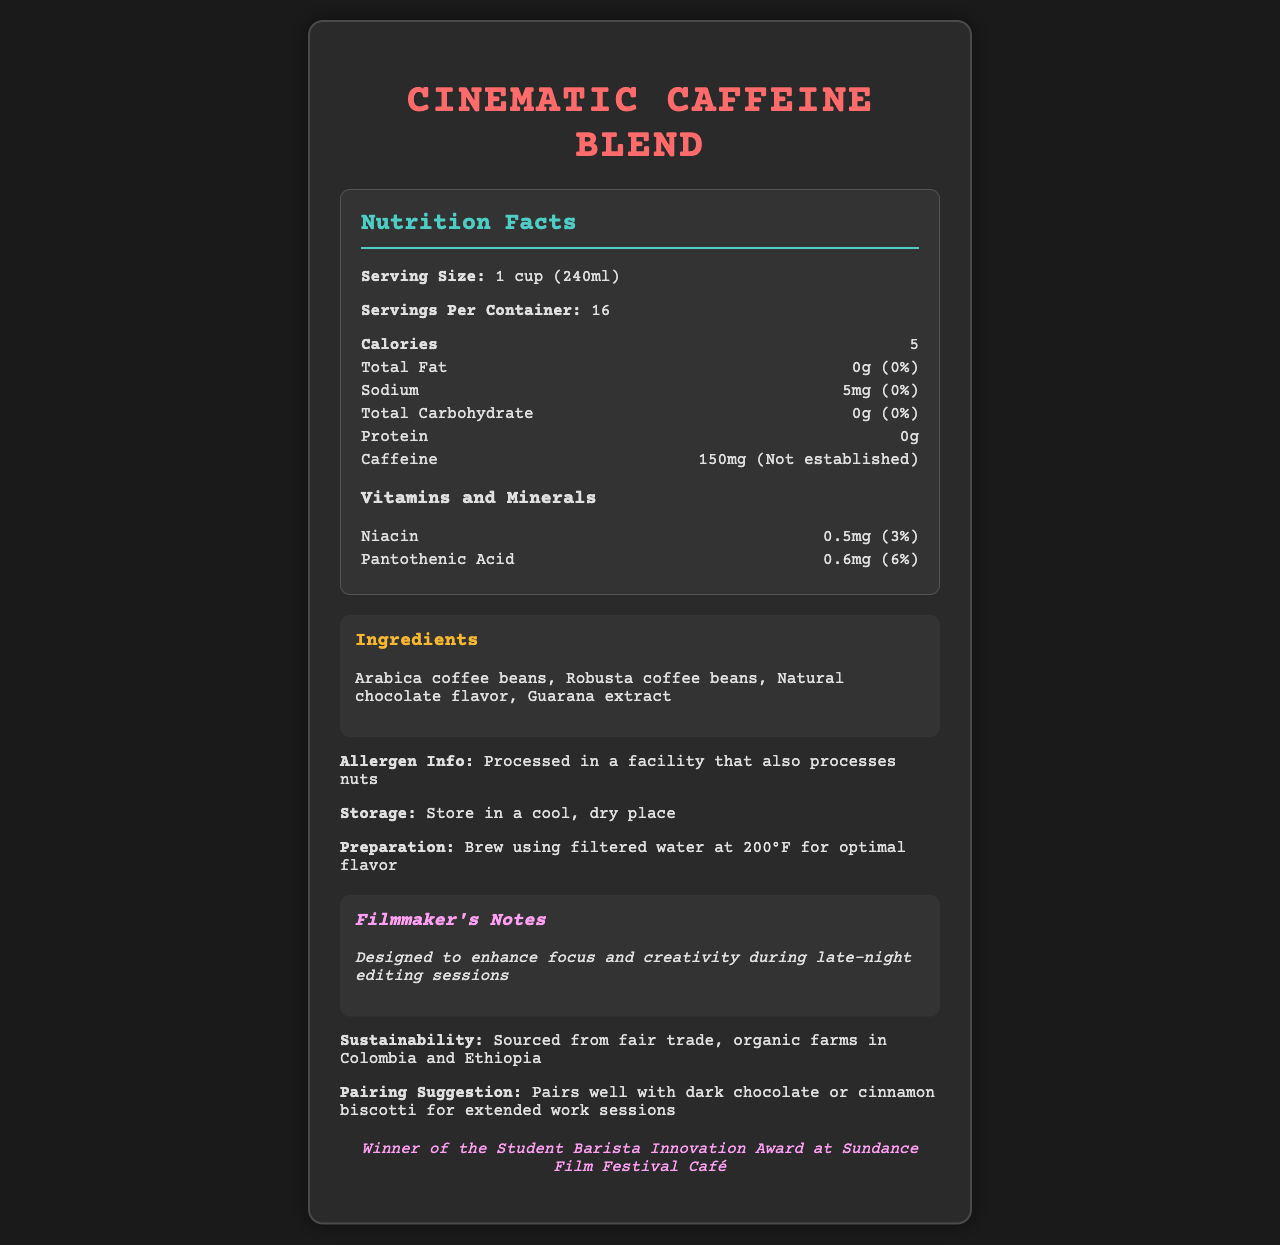What is the serving size of the Cinematic Caffeine Blend? The Nutrition Facts label lists the serving size as "1 cup (240ml)".
Answer: 1 cup (240ml) How many servings are in one container? The document specifies that there are 16 servings per container.
Answer: 16 What is the main source of flavor added to the coffee blend? Under ingredients, "Natural chocolate flavor" is listed as one of the components.
Answer: Natural chocolate flavor How much sodium is in one serving? The label shows sodium content as "5mg".
Answer: 5mg What specific vitamin contributes to 6% of the daily value? The vitamins and minerals section indicates that Pantothenic Acid contributes 6% of the daily value.
Answer: Pantothenic Acid What is the caffeine content per serving? The nutrition item for caffeine lists it as "150mg".
Answer: 150mg Which of the following awards has the product won? A. Best Coffee Blend at Coffee Expo B. Student Barista Innovation Award at Sundance Film Festival Café C. Most Sustainable Coffee of the Year D. People's Choice Award at Coffee Lovers Meeting The awards section states: "Winner of the Student Barista Innovation Award at Sundance Film Festival Café".
Answer: B What preparation instructions are given for brewing the coffee? A. Use filtered water at 180°F B. Use purified water at 190°F C. Use filtered water at 200°F D. Use tap water at 195°F The preparation instructions specify: "Brew using filtered water at 200°F for optimal flavor".
Answer: C Is this product suitable for people with nut allergies? The allergen info states: "Processed in a facility that also processes nuts".
Answer: No Summarize the main idea of this document. The document encompasses various aspects of the Cinematic Caffeine Blend from nutritional details to its awards and sustainability, catering specifically to filmmakers and students requiring long-lasting focus.
Answer: The document provides comprehensive details about the Cinematic Caffeine Blend, outlining its nutritional facts, ingredients, awards, sustainability efforts, and recommendations for usage. It highlights the coffee's benefits for late-night editing, suggesting it enhances focus and creativity, and includes detailed preparation and storage instructions. How much total fat is contained in a serving? The total fat amount in one serving is listed as "0g".
Answer: 0g Can the exact amount of daily value for caffeine be determined from the document? The daily value for caffeine is noted as "Not established".
Answer: No What are the storage instructions for the Cinematic Caffeine Blend? The label advises to "Store in a cool, dry place".
Answer: Store in a cool, dry place What is the calorie count per serving? The calorie count is specified as "5".
Answer: 5 Where is the coffee blend sourced from? The sustainability section states it is "Sourced from fair trade, organic farms in Colombia and Ethiopia".
Answer: Fair trade, organic farms in Colombia and Ethiopia Which ingredient is specifically noted for its extract form? The ingredients list includes "Guarana extract".
Answer: Guarana extract 